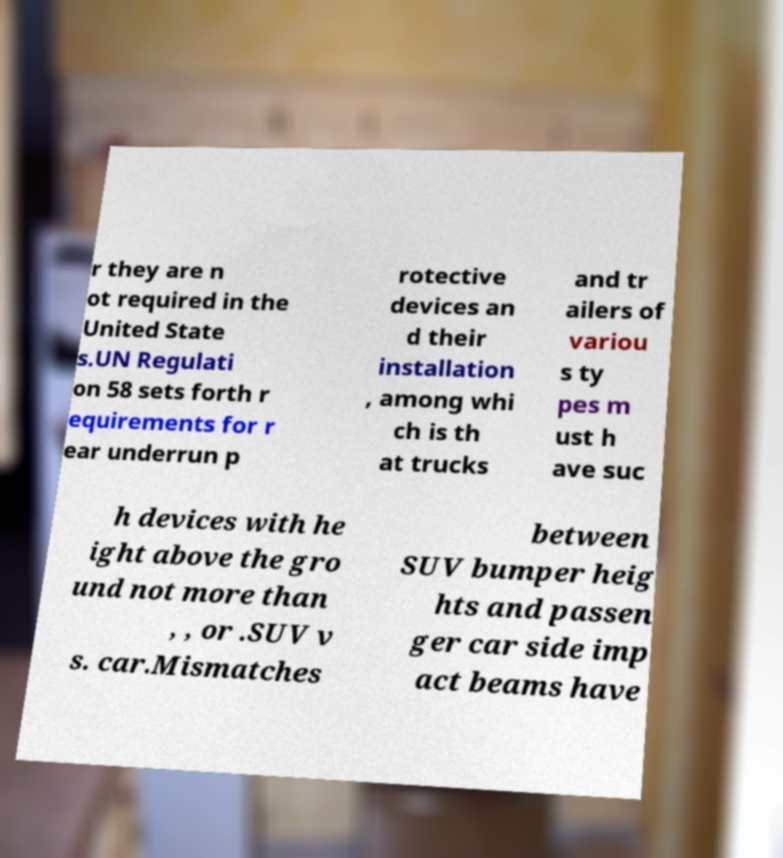For documentation purposes, I need the text within this image transcribed. Could you provide that? r they are n ot required in the United State s.UN Regulati on 58 sets forth r equirements for r ear underrun p rotective devices an d their installation , among whi ch is th at trucks and tr ailers of variou s ty pes m ust h ave suc h devices with he ight above the gro und not more than , , or .SUV v s. car.Mismatches between SUV bumper heig hts and passen ger car side imp act beams have 